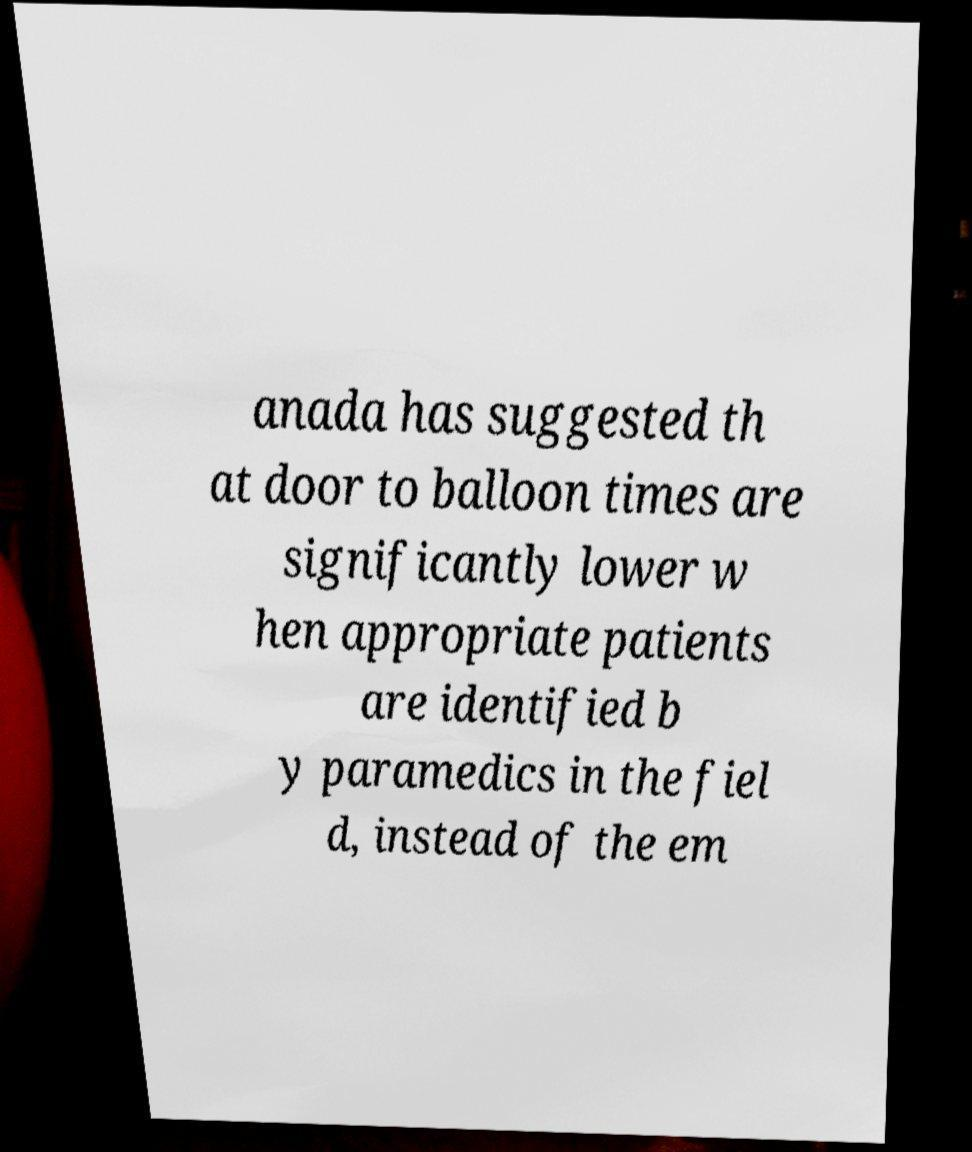Can you accurately transcribe the text from the provided image for me? anada has suggested th at door to balloon times are significantly lower w hen appropriate patients are identified b y paramedics in the fiel d, instead of the em 